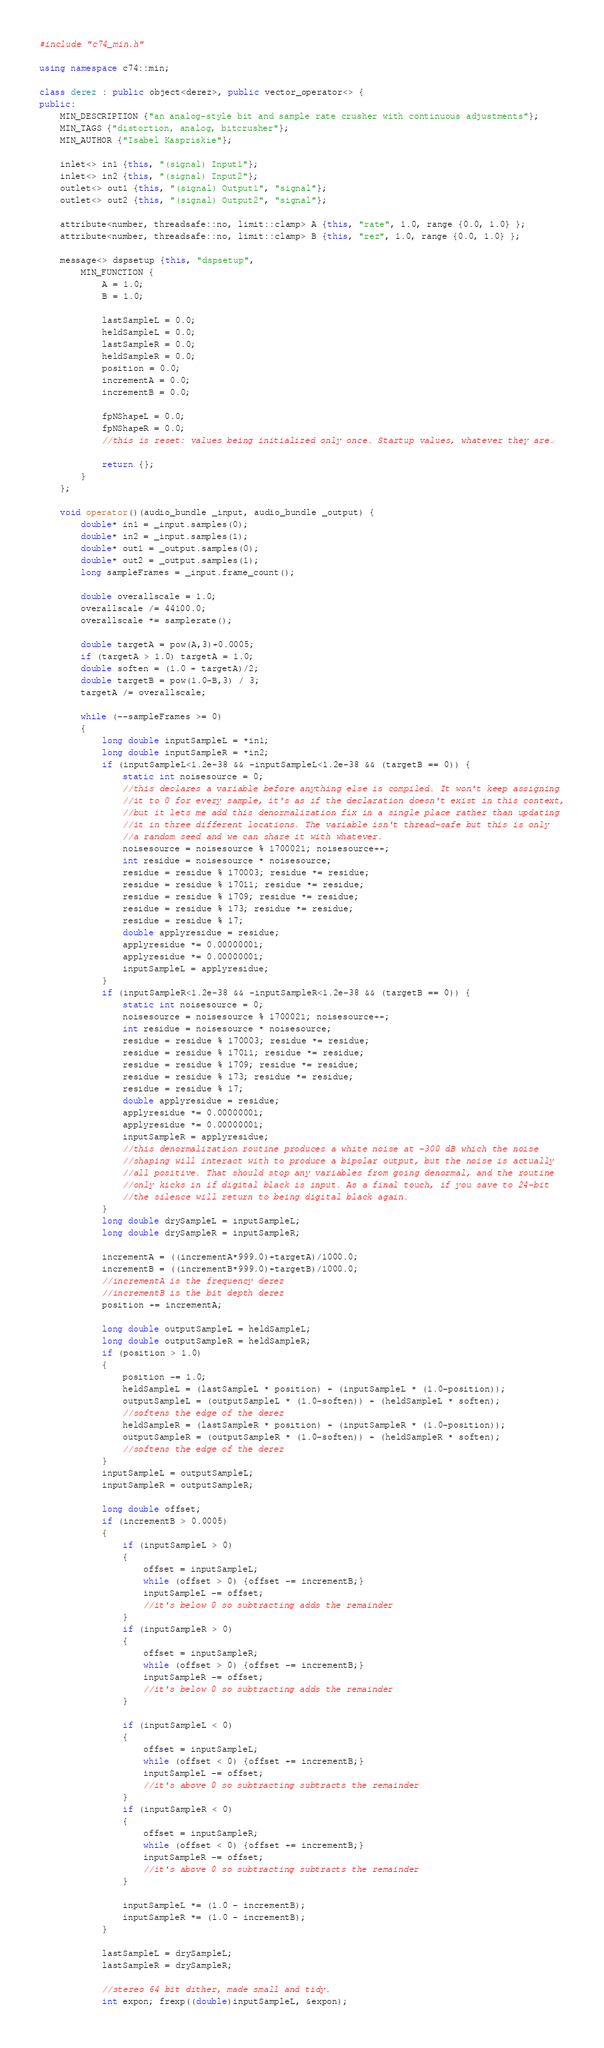Convert code to text. <code><loc_0><loc_0><loc_500><loc_500><_C++_>#include "c74_min.h"

using namespace c74::min;

class derez : public object<derez>, public vector_operator<> {
public:
	MIN_DESCRIPTION {"an analog-style bit and sample rate crusher with continuous adjustments"};
	MIN_TAGS {"distortion, analog, bitcrusher"};
	MIN_AUTHOR {"Isabel Kaspriskie"};

	inlet<> in1 {this, "(signal) Input1"};
	inlet<> in2 {this, "(signal) Input2"};
	outlet<> out1 {this, "(signal) Output1", "signal"};
	outlet<> out2 {this, "(signal) Output2", "signal"};

	attribute<number, threadsafe::no, limit::clamp> A {this, "rate", 1.0, range {0.0, 1.0} };
	attribute<number, threadsafe::no, limit::clamp> B {this, "rez", 1.0, range {0.0, 1.0} };

	message<> dspsetup {this, "dspsetup",
		MIN_FUNCTION {
			A = 1.0;
			B = 1.0;
			
			lastSampleL = 0.0;
			heldSampleL = 0.0;
			lastSampleR = 0.0;
			heldSampleR = 0.0;
			position = 0.0;
			incrementA = 0.0;
			incrementB = 0.0;
			
			fpNShapeL = 0.0;
			fpNShapeR = 0.0;
			//this is reset: values being initialized only once. Startup values, whatever they are.
			
			return {};
		}
	};

	void operator()(audio_bundle _input, audio_bundle _output) {
		double* in1 = _input.samples(0);
		double* in2 = _input.samples(1);
		double* out1 = _output.samples(0);
		double* out2 = _output.samples(1);
		long sampleFrames = _input.frame_count();

		double overallscale = 1.0;
		overallscale /= 44100.0;
		overallscale *= samplerate();
		
		double targetA = pow(A,3)+0.0005;
		if (targetA > 1.0) targetA = 1.0;
		double soften = (1.0 + targetA)/2;
		double targetB = pow(1.0-B,3) / 3;
		targetA /= overallscale;
	
	    while (--sampleFrames >= 0)
	    {
			long double inputSampleL = *in1;
			long double inputSampleR = *in2;
			if (inputSampleL<1.2e-38 && -inputSampleL<1.2e-38 && (targetB == 0)) {
				static int noisesource = 0;
				//this declares a variable before anything else is compiled. It won't keep assigning
				//it to 0 for every sample, it's as if the declaration doesn't exist in this context,
				//but it lets me add this denormalization fix in a single place rather than updating
				//it in three different locations. The variable isn't thread-safe but this is only
				//a random seed and we can share it with whatever.
				noisesource = noisesource % 1700021; noisesource++;
				int residue = noisesource * noisesource;
				residue = residue % 170003; residue *= residue;
				residue = residue % 17011; residue *= residue;
				residue = residue % 1709; residue *= residue;
				residue = residue % 173; residue *= residue;
				residue = residue % 17;
				double applyresidue = residue;
				applyresidue *= 0.00000001;
				applyresidue *= 0.00000001;
				inputSampleL = applyresidue;
			}
			if (inputSampleR<1.2e-38 && -inputSampleR<1.2e-38 && (targetB == 0)) {
				static int noisesource = 0;
				noisesource = noisesource % 1700021; noisesource++;
				int residue = noisesource * noisesource;
				residue = residue % 170003; residue *= residue;
				residue = residue % 17011; residue *= residue;
				residue = residue % 1709; residue *= residue;
				residue = residue % 173; residue *= residue;
				residue = residue % 17;
				double applyresidue = residue;
				applyresidue *= 0.00000001;
				applyresidue *= 0.00000001;
				inputSampleR = applyresidue;
				//this denormalization routine produces a white noise at -300 dB which the noise
				//shaping will interact with to produce a bipolar output, but the noise is actually
				//all positive. That should stop any variables from going denormal, and the routine
				//only kicks in if digital black is input. As a final touch, if you save to 24-bit
				//the silence will return to being digital black again.
			}
			long double drySampleL = inputSampleL;
			long double drySampleR = inputSampleR;
			
			incrementA = ((incrementA*999.0)+targetA)/1000.0;
			incrementB = ((incrementB*999.0)+targetB)/1000.0;
			//incrementA is the frequency derez
			//incrementB is the bit depth derez
			position += incrementA;
			
			long double outputSampleL = heldSampleL;
			long double outputSampleR = heldSampleR;
			if (position > 1.0)
			{
				position -= 1.0;
				heldSampleL = (lastSampleL * position) + (inputSampleL * (1.0-position));
				outputSampleL = (outputSampleL * (1.0-soften)) + (heldSampleL * soften);
				//softens the edge of the derez
				heldSampleR = (lastSampleR * position) + (inputSampleR * (1.0-position));
				outputSampleR = (outputSampleR * (1.0-soften)) + (heldSampleR * soften);
				//softens the edge of the derez
			}
			inputSampleL = outputSampleL;
			inputSampleR = outputSampleR;
			
			long double offset;
			if (incrementB > 0.0005)
			{
				if (inputSampleL > 0)
				{
					offset = inputSampleL;
					while (offset > 0) {offset -= incrementB;}
					inputSampleL -= offset;
					//it's below 0 so subtracting adds the remainder
				}
				if (inputSampleR > 0)
				{
					offset = inputSampleR;
					while (offset > 0) {offset -= incrementB;}
					inputSampleR -= offset;
					//it's below 0 so subtracting adds the remainder
				}
				
				if (inputSampleL < 0)
				{
					offset = inputSampleL;
					while (offset < 0) {offset += incrementB;}
					inputSampleL -= offset;
					//it's above 0 so subtracting subtracts the remainder
				}
				if (inputSampleR < 0)
				{
					offset = inputSampleR;
					while (offset < 0) {offset += incrementB;}
					inputSampleR -= offset;
					//it's above 0 so subtracting subtracts the remainder
				}
				
				inputSampleL *= (1.0 - incrementB);
				inputSampleR *= (1.0 - incrementB);
			}
			
			lastSampleL = drySampleL;
			lastSampleR = drySampleR;
			
			//stereo 64 bit dither, made small and tidy.
			int expon; frexp((double)inputSampleL, &expon);</code> 